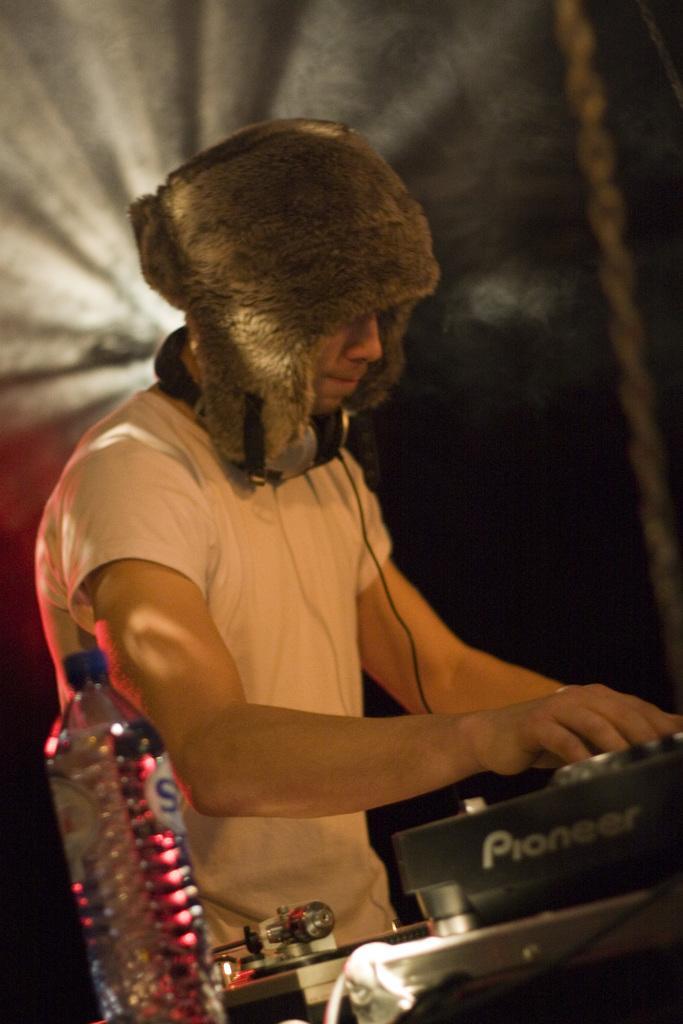How would you summarize this image in a sentence or two? In this image we can see a person wearing cap. He is having headset on the neck. In front of him there is a DJ controller. Also there is a bottle. 